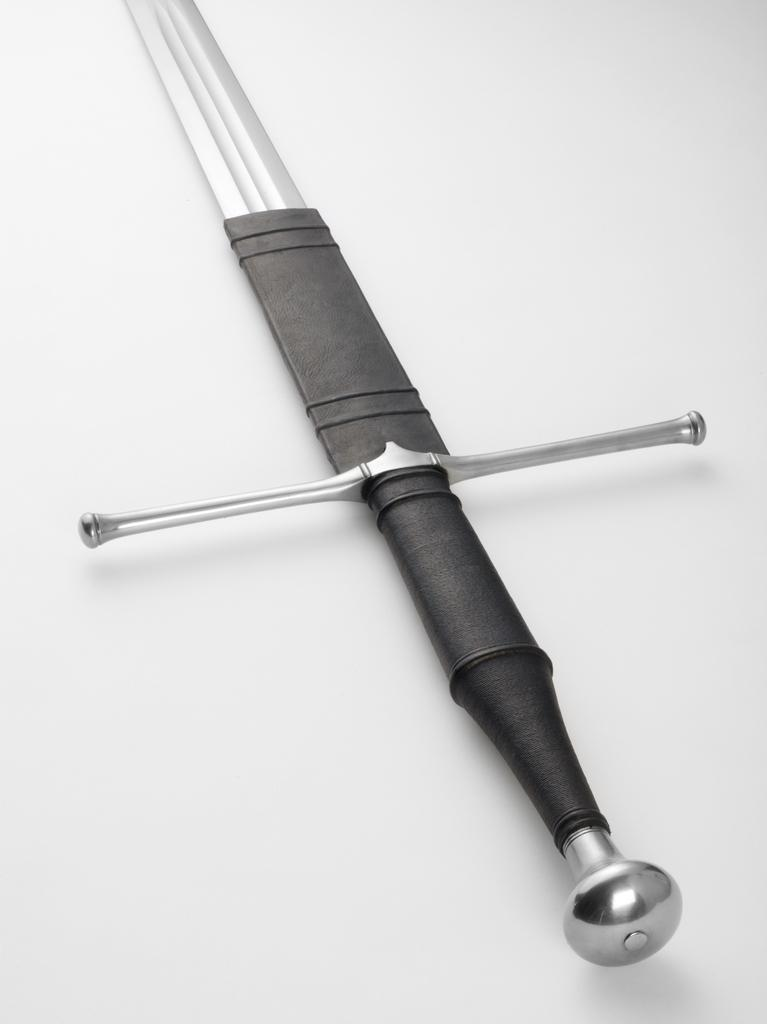What is located in the center of the image? There is a blade, a rain-guard, a grip, and a pommel in the center of the image. Can you describe the individual components in the center of the image? The blade is likely a sharp cutting edge, the rain-guard is a protective covering, the grip is a handle for holding the object, and the pommel is a decorative or functional end piece. What is the color of the background in the image? The background of the image is colored. What position does the baseball player hold in the image? There is no baseball player or any reference to baseball in the image. What type of room is depicted in the image? The image does not depict a room; it features a blade, a rain-guard, a grip, and a pommel in the center, with a colored background. 